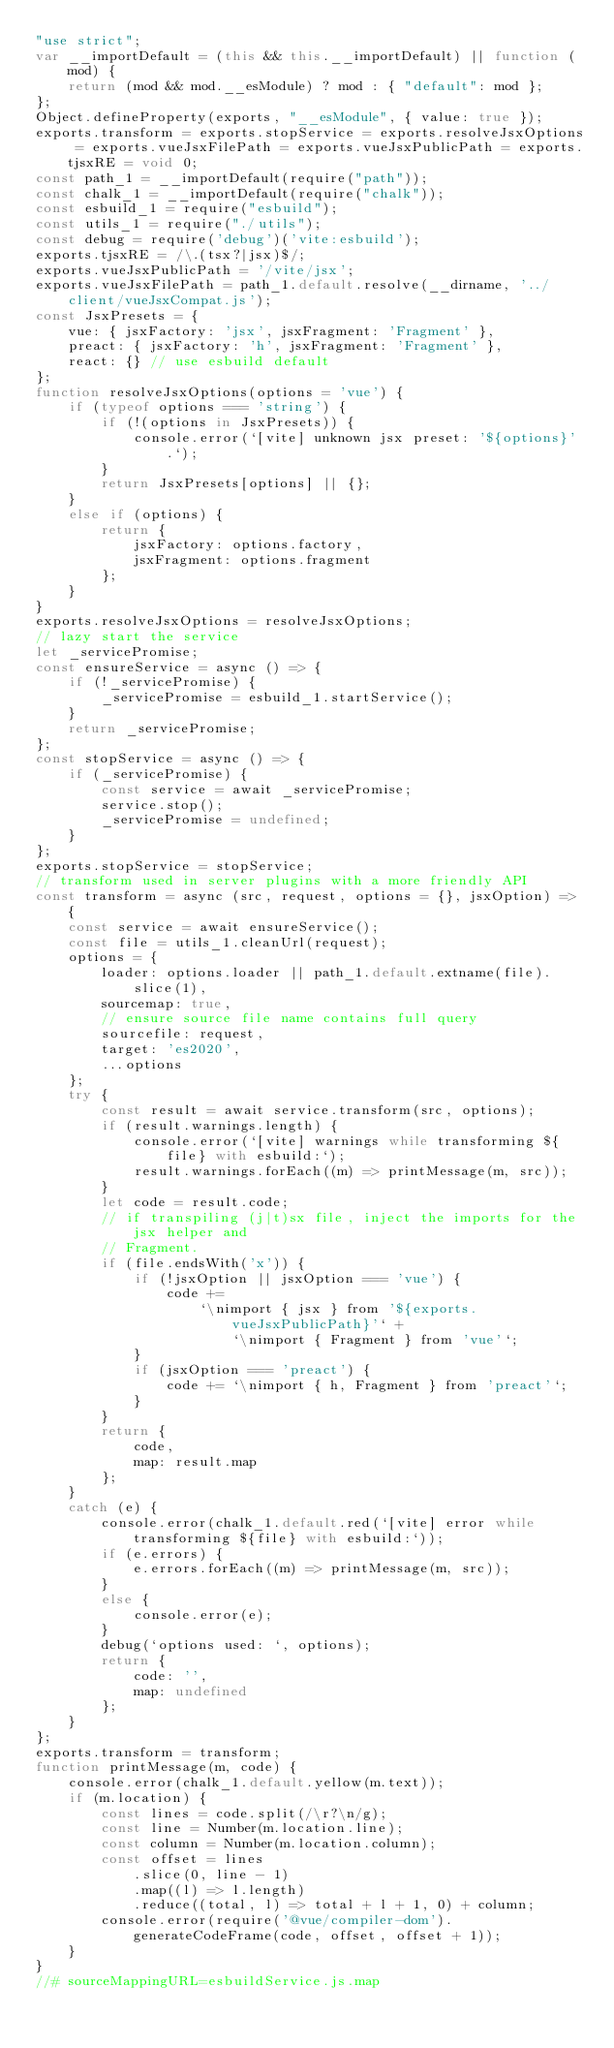<code> <loc_0><loc_0><loc_500><loc_500><_JavaScript_>"use strict";
var __importDefault = (this && this.__importDefault) || function (mod) {
    return (mod && mod.__esModule) ? mod : { "default": mod };
};
Object.defineProperty(exports, "__esModule", { value: true });
exports.transform = exports.stopService = exports.resolveJsxOptions = exports.vueJsxFilePath = exports.vueJsxPublicPath = exports.tjsxRE = void 0;
const path_1 = __importDefault(require("path"));
const chalk_1 = __importDefault(require("chalk"));
const esbuild_1 = require("esbuild");
const utils_1 = require("./utils");
const debug = require('debug')('vite:esbuild');
exports.tjsxRE = /\.(tsx?|jsx)$/;
exports.vueJsxPublicPath = '/vite/jsx';
exports.vueJsxFilePath = path_1.default.resolve(__dirname, '../client/vueJsxCompat.js');
const JsxPresets = {
    vue: { jsxFactory: 'jsx', jsxFragment: 'Fragment' },
    preact: { jsxFactory: 'h', jsxFragment: 'Fragment' },
    react: {} // use esbuild default
};
function resolveJsxOptions(options = 'vue') {
    if (typeof options === 'string') {
        if (!(options in JsxPresets)) {
            console.error(`[vite] unknown jsx preset: '${options}'.`);
        }
        return JsxPresets[options] || {};
    }
    else if (options) {
        return {
            jsxFactory: options.factory,
            jsxFragment: options.fragment
        };
    }
}
exports.resolveJsxOptions = resolveJsxOptions;
// lazy start the service
let _servicePromise;
const ensureService = async () => {
    if (!_servicePromise) {
        _servicePromise = esbuild_1.startService();
    }
    return _servicePromise;
};
const stopService = async () => {
    if (_servicePromise) {
        const service = await _servicePromise;
        service.stop();
        _servicePromise = undefined;
    }
};
exports.stopService = stopService;
// transform used in server plugins with a more friendly API
const transform = async (src, request, options = {}, jsxOption) => {
    const service = await ensureService();
    const file = utils_1.cleanUrl(request);
    options = {
        loader: options.loader || path_1.default.extname(file).slice(1),
        sourcemap: true,
        // ensure source file name contains full query
        sourcefile: request,
        target: 'es2020',
        ...options
    };
    try {
        const result = await service.transform(src, options);
        if (result.warnings.length) {
            console.error(`[vite] warnings while transforming ${file} with esbuild:`);
            result.warnings.forEach((m) => printMessage(m, src));
        }
        let code = result.code;
        // if transpiling (j|t)sx file, inject the imports for the jsx helper and
        // Fragment.
        if (file.endsWith('x')) {
            if (!jsxOption || jsxOption === 'vue') {
                code +=
                    `\nimport { jsx } from '${exports.vueJsxPublicPath}'` +
                        `\nimport { Fragment } from 'vue'`;
            }
            if (jsxOption === 'preact') {
                code += `\nimport { h, Fragment } from 'preact'`;
            }
        }
        return {
            code,
            map: result.map
        };
    }
    catch (e) {
        console.error(chalk_1.default.red(`[vite] error while transforming ${file} with esbuild:`));
        if (e.errors) {
            e.errors.forEach((m) => printMessage(m, src));
        }
        else {
            console.error(e);
        }
        debug(`options used: `, options);
        return {
            code: '',
            map: undefined
        };
    }
};
exports.transform = transform;
function printMessage(m, code) {
    console.error(chalk_1.default.yellow(m.text));
    if (m.location) {
        const lines = code.split(/\r?\n/g);
        const line = Number(m.location.line);
        const column = Number(m.location.column);
        const offset = lines
            .slice(0, line - 1)
            .map((l) => l.length)
            .reduce((total, l) => total + l + 1, 0) + column;
        console.error(require('@vue/compiler-dom').generateCodeFrame(code, offset, offset + 1));
    }
}
//# sourceMappingURL=esbuildService.js.map</code> 